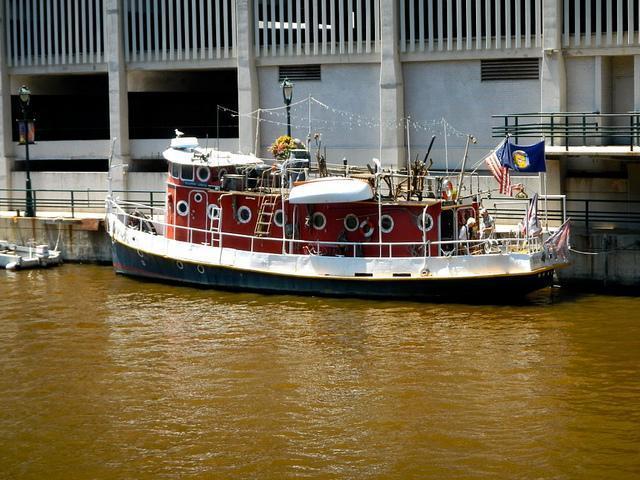How many people are on the boat?
Give a very brief answer. 2. How many train cars are there?
Give a very brief answer. 0. 